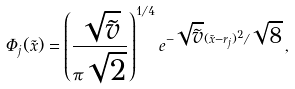Convert formula to latex. <formula><loc_0><loc_0><loc_500><loc_500>\Phi _ { j } ( \tilde { x } ) = \left ( \frac { \sqrt { \tilde { v } } } { \pi \sqrt { 2 } } \right ) ^ { 1 / 4 } e ^ { - \sqrt { \tilde { v } } ( \tilde { x } - r _ { j } ) ^ { 2 } / \sqrt { 8 } } \, ,</formula> 